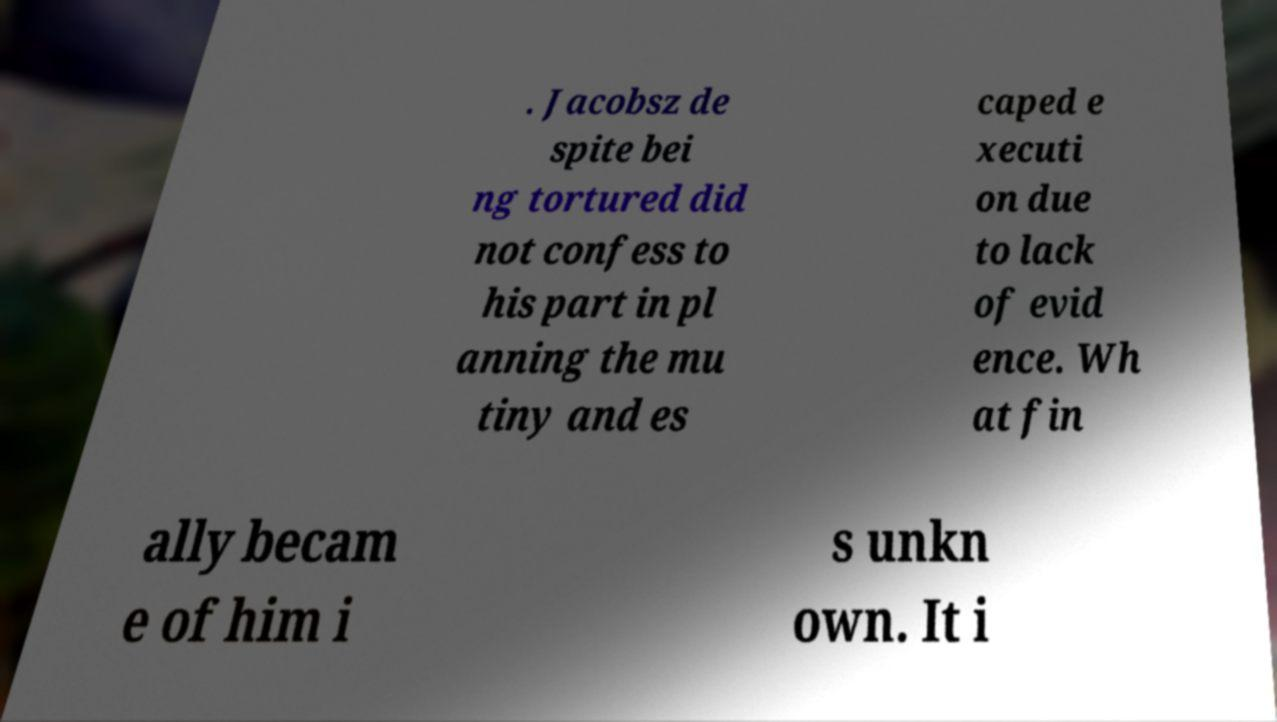For documentation purposes, I need the text within this image transcribed. Could you provide that? . Jacobsz de spite bei ng tortured did not confess to his part in pl anning the mu tiny and es caped e xecuti on due to lack of evid ence. Wh at fin ally becam e of him i s unkn own. It i 